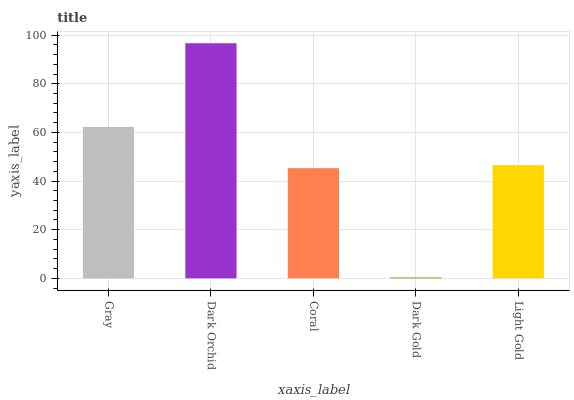Is Dark Gold the minimum?
Answer yes or no. Yes. Is Dark Orchid the maximum?
Answer yes or no. Yes. Is Coral the minimum?
Answer yes or no. No. Is Coral the maximum?
Answer yes or no. No. Is Dark Orchid greater than Coral?
Answer yes or no. Yes. Is Coral less than Dark Orchid?
Answer yes or no. Yes. Is Coral greater than Dark Orchid?
Answer yes or no. No. Is Dark Orchid less than Coral?
Answer yes or no. No. Is Light Gold the high median?
Answer yes or no. Yes. Is Light Gold the low median?
Answer yes or no. Yes. Is Coral the high median?
Answer yes or no. No. Is Gray the low median?
Answer yes or no. No. 